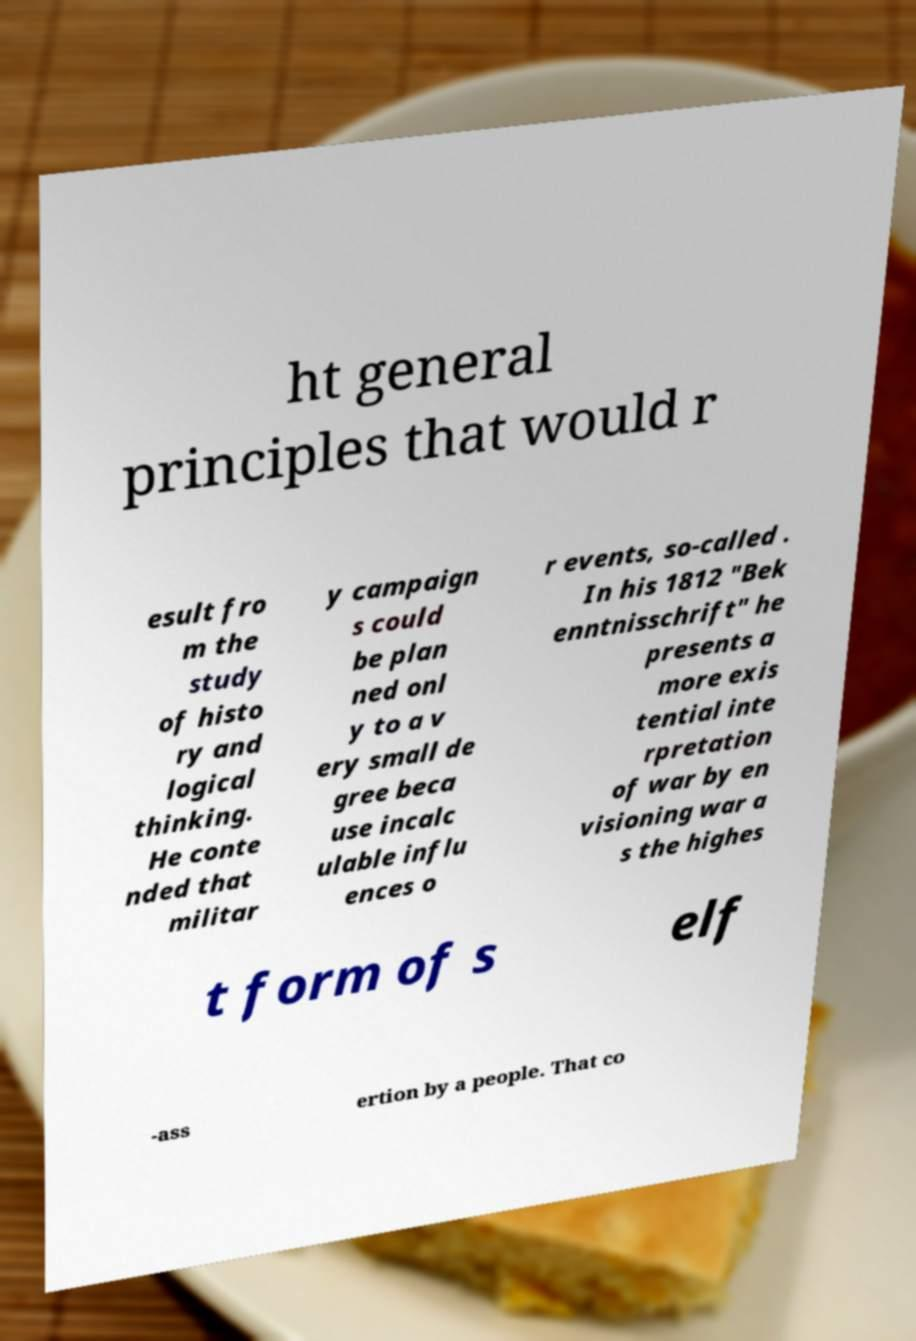For documentation purposes, I need the text within this image transcribed. Could you provide that? ht general principles that would r esult fro m the study of histo ry and logical thinking. He conte nded that militar y campaign s could be plan ned onl y to a v ery small de gree beca use incalc ulable influ ences o r events, so-called . In his 1812 "Bek enntnisschrift" he presents a more exis tential inte rpretation of war by en visioning war a s the highes t form of s elf -ass ertion by a people. That co 